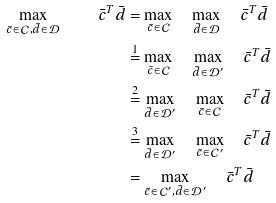<formula> <loc_0><loc_0><loc_500><loc_500>\max _ { \bar { c } \in \mathcal { C } , \bar { d } \in \mathcal { D } } \quad \bar { c } ^ { T } \bar { d } & = \max _ { \bar { c } \in \mathcal { C } } \quad \max _ { \bar { d } \in \mathcal { D } } \quad \bar { c } ^ { T } \bar { d } \\ & \overset { 1 } { = } \max _ { \bar { c } \in \mathcal { C } } \quad \max _ { \bar { d } \in \mathcal { D } ^ { \prime } } \quad \bar { c } ^ { T } \bar { d } \\ & \overset { 2 } { = } \max _ { \bar { d } \in \mathcal { D } ^ { \prime } } \quad \max _ { \bar { c } \in \mathcal { C } } \quad \bar { c } ^ { T } \bar { d } \\ & \overset { 3 } { = } \max _ { \bar { d } \in \mathcal { D } ^ { \prime } } \quad \max _ { \bar { c } \in \mathcal { C } ^ { \prime } } \quad \bar { c } ^ { T } \bar { d } \\ & = \max _ { \bar { c } \in \mathcal { C } ^ { \prime } , \bar { d } \in \mathcal { D } ^ { \prime } } \quad \bar { c } ^ { T } \bar { d }</formula> 